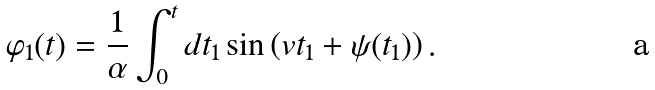Convert formula to latex. <formula><loc_0><loc_0><loc_500><loc_500>\varphi _ { 1 } ( t ) = \frac { 1 } { \alpha } \int _ { 0 } ^ { t } d t _ { 1 } \sin \left ( v t _ { 1 } + \psi ( t _ { 1 } ) \right ) .</formula> 